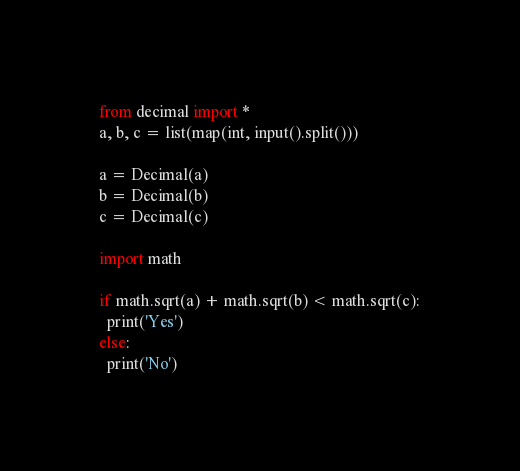<code> <loc_0><loc_0><loc_500><loc_500><_Python_>from decimal import *
a, b, c = list(map(int, input().split()))

a = Decimal(a)
b = Decimal(b)
c = Decimal(c)

import math

if math.sqrt(a) + math.sqrt(b) < math.sqrt(c):
  print('Yes')
else:
  print('No')</code> 